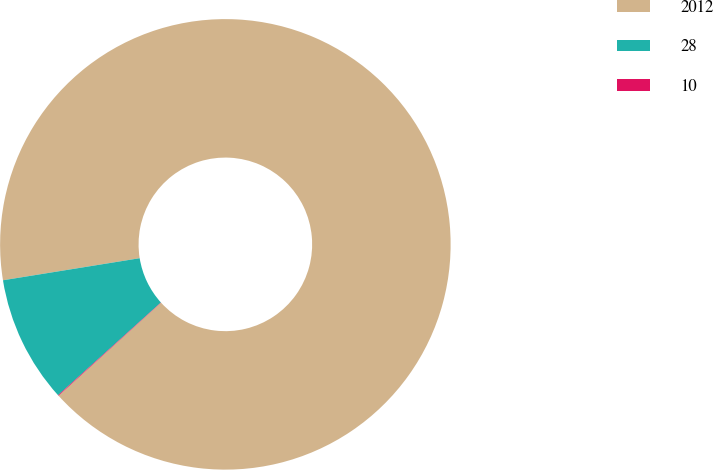Convert chart to OTSL. <chart><loc_0><loc_0><loc_500><loc_500><pie_chart><fcel>2012<fcel>28<fcel>10<nl><fcel>90.82%<fcel>9.13%<fcel>0.05%<nl></chart> 